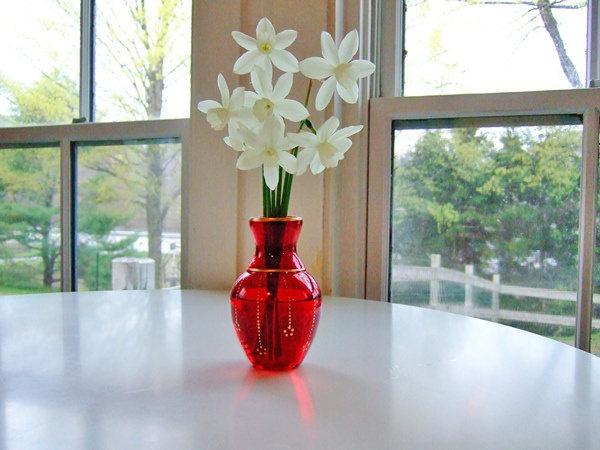Describe the objects in this image and their specific colors. I can see dining table in white, lightgray, and darkgray tones and vase in white, maroon, brown, and black tones in this image. 